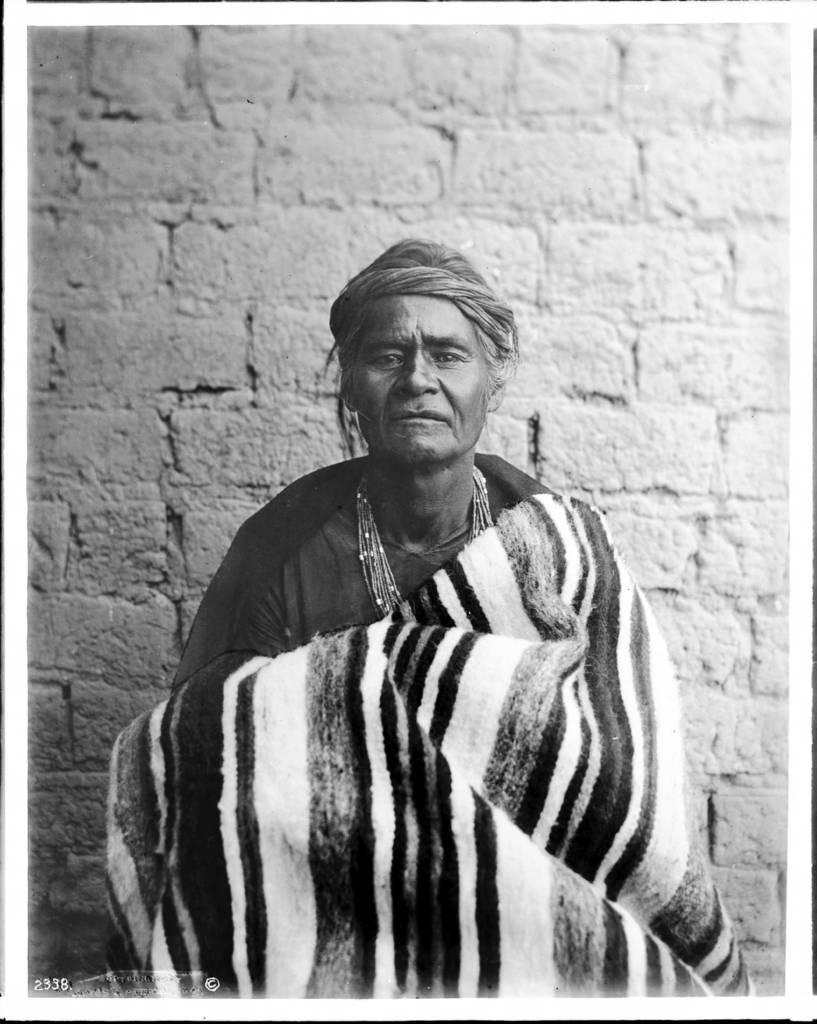What is present in the image? There is a person in the image. Can you describe the person's attire? The person is wearing clothes and a neck chain. What can be seen in the background of the image? There is a wall in the image. What other object is present in the image? There is a blanket in the image. What type of sorting algorithm does the person in the image use to organize their clothes? There is no indication in the image that the person is sorting their clothes or using any sorting algorithm. 